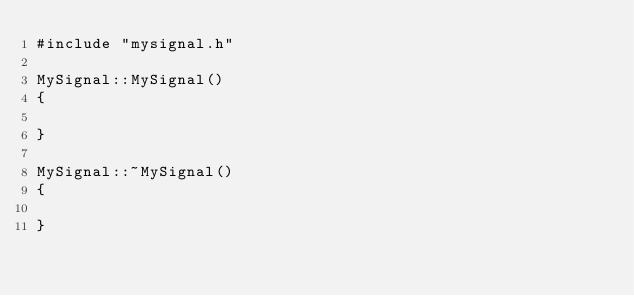<code> <loc_0><loc_0><loc_500><loc_500><_C++_>#include "mysignal.h"

MySignal::MySignal()
{

}

MySignal::~MySignal()
{

}

</code> 